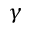<formula> <loc_0><loc_0><loc_500><loc_500>\gamma</formula> 